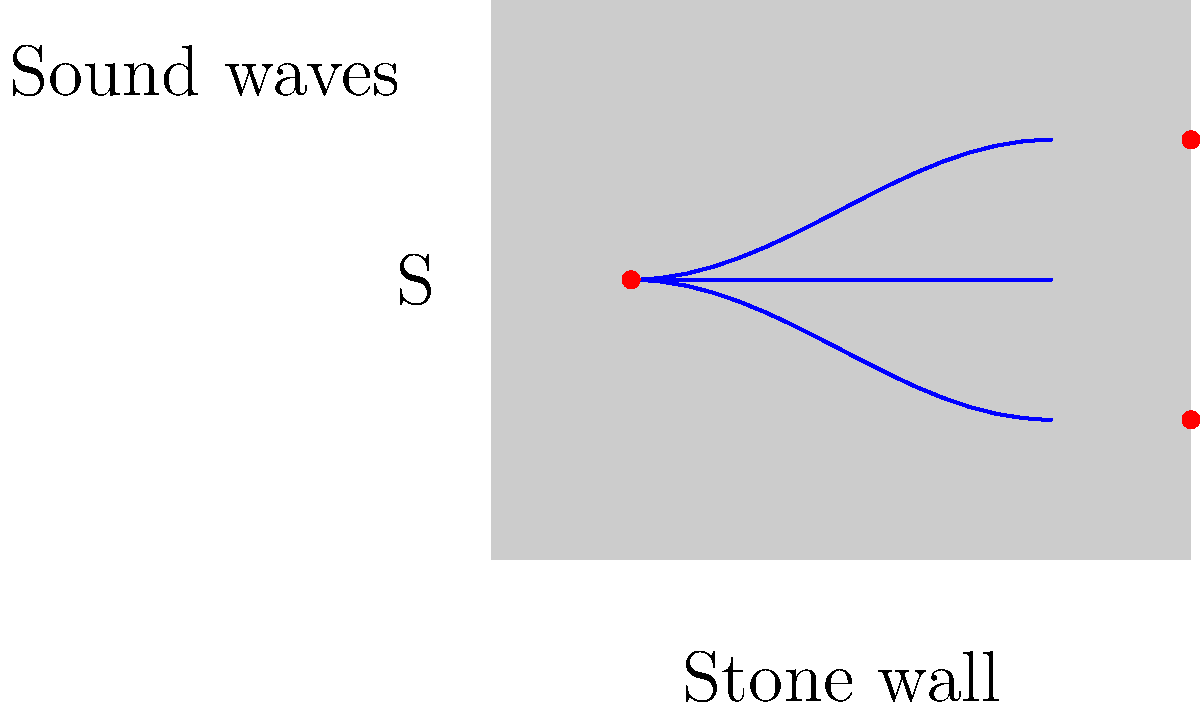In a stone-built monastery, a sound source S emits waves that reflect off the stone walls. Given that the speed of sound in air is 343 m/s and the frequency of the sound is 500 Hz, calculate the wavelength of the sound waves inside the monastery. How might this affect the acoustics of choral performances in the space? To solve this problem, we'll follow these steps:

1. Recall the wave equation: $v = f\lambda$, where $v$ is the speed of sound, $f$ is the frequency, and $\lambda$ is the wavelength.

2. We are given:
   - Speed of sound in air, $v = 343$ m/s
   - Frequency of the sound, $f = 500$ Hz

3. Rearrange the wave equation to solve for wavelength:
   $\lambda = \frac{v}{f}$

4. Substitute the known values:
   $\lambda = \frac{343 \text{ m/s}}{500 \text{ Hz}} = 0.686$ m

5. The wavelength of the sound waves is 0.686 meters or about 68.6 cm.

6. Effect on acoustics:
   - This wavelength is comparable to the dimensions of many architectural features in a monastery (e.g., columns, arches, alcoves).
   - When the wavelength is similar to the size of objects or spaces, it can lead to strong resonances and standing waves.
   - In choral performances, this could result in:
     a) Enhanced volume of certain frequencies (those that match the room's resonant frequencies)
     b) Longer reverberation times, especially for lower frequencies
     c) Potential for interference patterns, creating areas of constructive and destructive interference throughout the space
   - These acoustic properties could contribute to the rich, reverberant sound often associated with monastic choral music, but might also create challenges in clarity and balance for complex polyphonic works.
Answer: Wavelength: 0.686 m. Effects: enhanced resonance, longer reverberation, potential interference patterns. 